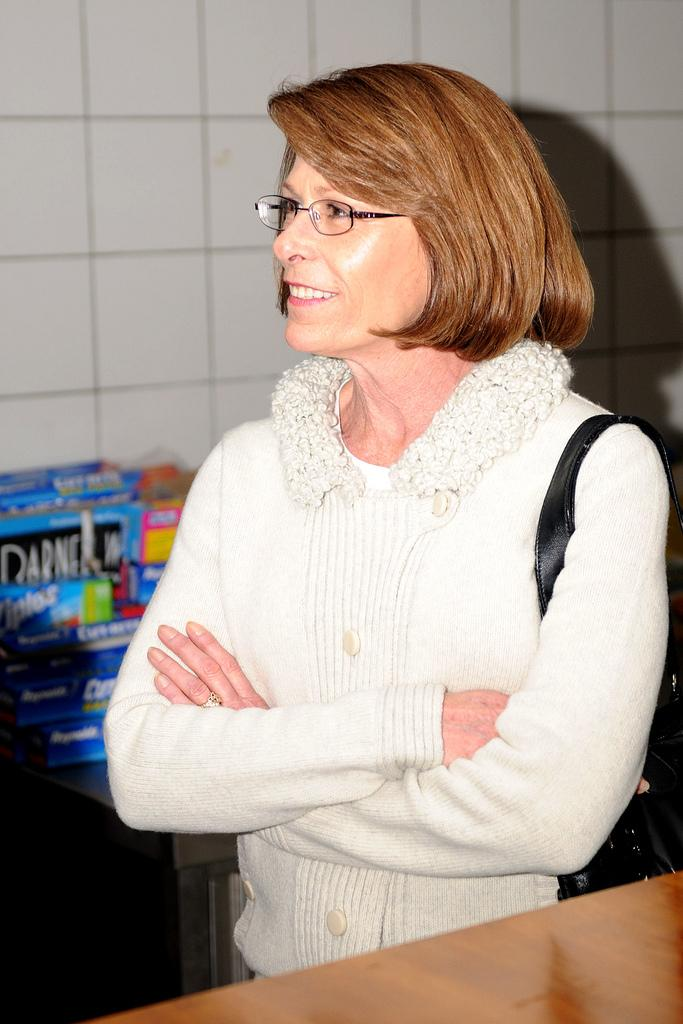Who is the main subject in the foreground of the image? There is a lady standing in the foreground of the image. What object can be seen at the bottom side of the image? There appears to be a table at the bottom side of the image. What type of objects are visible in the background of the image? Cardboard boxes are visible in the background of the image. How does the force of the fog affect the visibility in the image? There is no fog present in the image, so the force of the fog does not affect the visibility. 